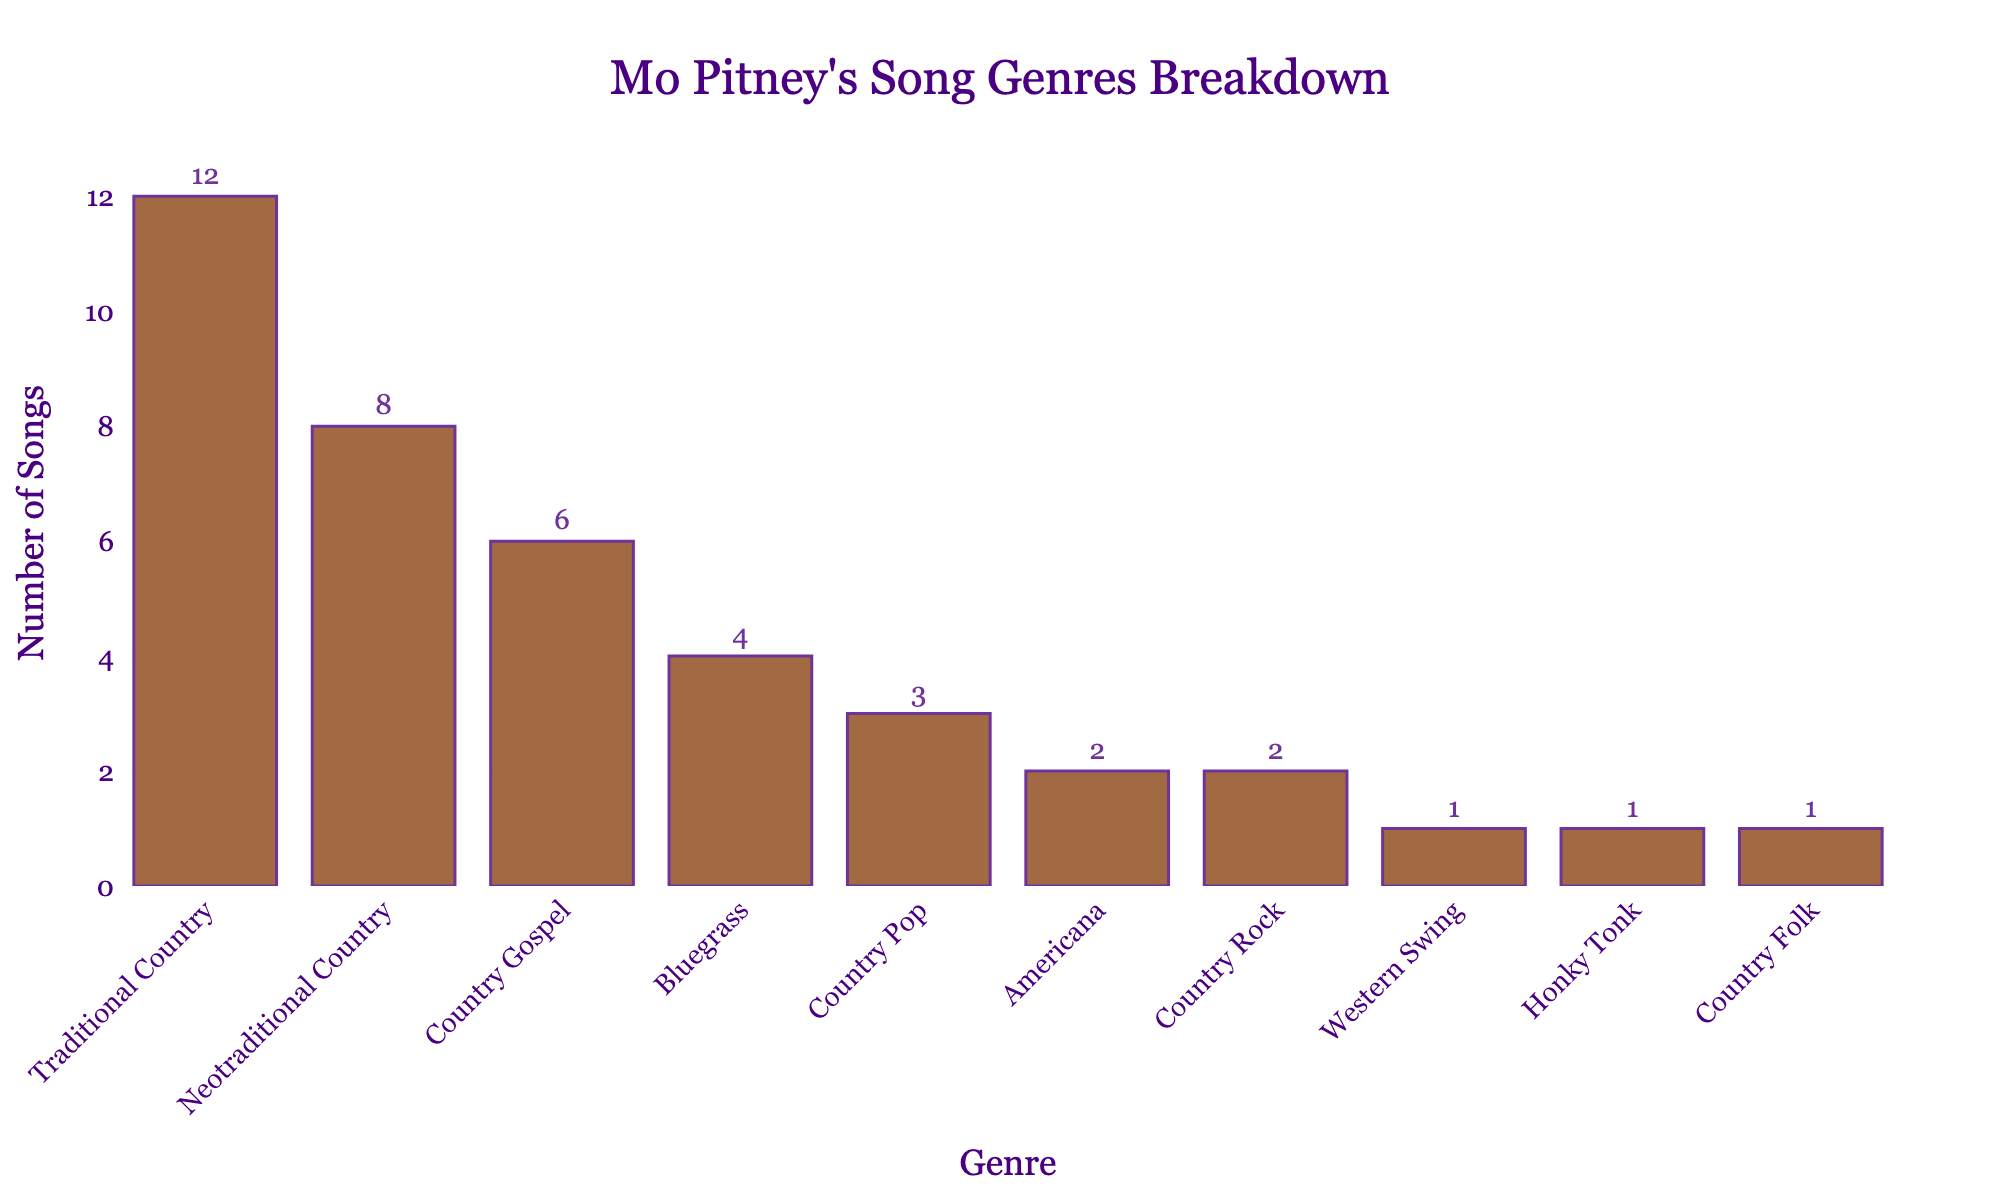what is the total number of songs for the top three genres? Add the number of songs for the top three genres listed: Traditional Country (12), Neotraditional Country (8), and Country Gospel (6). Thus, 12 + 8 + 6 equals 26.
Answer: 26 Which genre has the fewest number of songs and how many are there? Identify the genre with the smallest bar. Western Swing, Honky Tonk, and Country Folk each have the shortest bars with 1 song each.
Answer: Western Swing, Country Folk, and Honky Tonk, 1 each How many more songs does Traditional Country have compared to Bluegrass? Subtract the number of Bluegrass songs (4) from the number of Traditional Country songs (12). Thus, 12 - 4 equals 8.
Answer: 8 What is the combined total of Country Pop and Country Rock songs? Add the number of Country Pop songs (3) and Country Rock songs (2). Thus, 3 + 2 equals 5.
Answer: 5 Are there more Neotraditional Country songs than Americana songs? Compare the number of Neotraditional Country songs (8) with the number of Americana songs (2). Since 8 is greater than 2, there are more Neotraditional Country songs.
Answer: Yes Which genres have exactly 2 songs, and how are their bars positioned on the chart based on height? Identify the genres with a count of 2. Americana and Country Rock both have 2 songs each. Their bars are the same height, shorter than those of genres with more songs and taller than those with fewer songs.
Answer: Americana and Country Rock What is the difference in the number of songs between the genre with the most songs and the genre with the second most songs? Subtract the number of Neotraditional Country songs (8) from the number of Traditional Country songs (12). Thus, 12 - 8 equals 4.
Answer: 4 How many genres have more than 3 songs? Count the genres with bars representing more than 3 songs. They are Traditional Country (12), Neotraditional Country (8), Country Gospel (6), and Bluegrass (4). Thus, four genres have more than 3 songs.
Answer: 4 What percentage of Mo Pitney's songs are Traditional Country? First, calculate the total number of songs: 12 + 8 + 6 + 4 + 3 + 2 + 2 + 1 + 1 + 1 = 40. Then, divide the number of Traditional Country songs (12) by the total number of songs (40) and multiply by 100 to get the percentage. Thus, (12 / 40) * 100 equals 30%.
Answer: 30% Which genres have an equal number of songs and what is that number? Identify genres with the same number of songs by looking for bars of equal height. Americana and Country Rock both have 2 songs each.
Answer: Americana and Country Rock, 2 each 